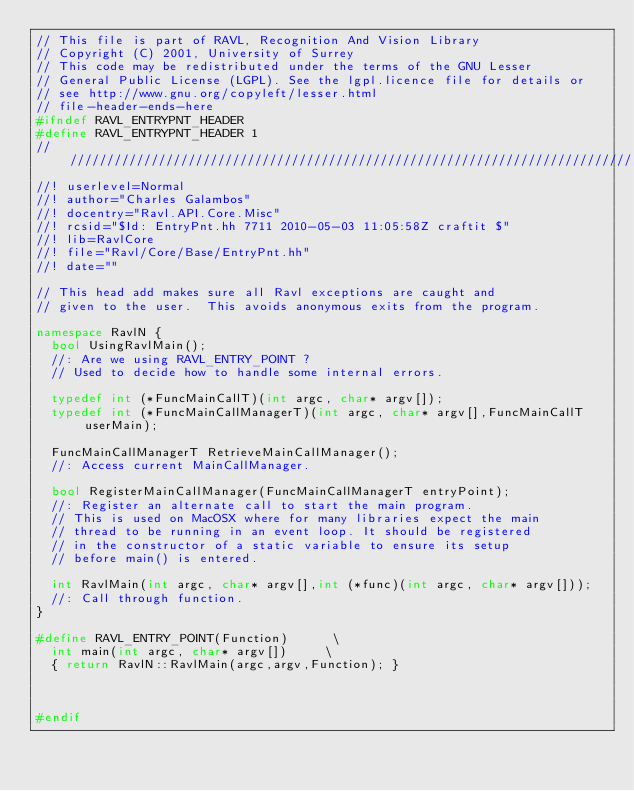<code> <loc_0><loc_0><loc_500><loc_500><_C++_>// This file is part of RAVL, Recognition And Vision Library 
// Copyright (C) 2001, University of Surrey
// This code may be redistributed under the terms of the GNU Lesser
// General Public License (LGPL). See the lgpl.licence file for details or
// see http://www.gnu.org/copyleft/lesser.html
// file-header-ends-here
#ifndef RAVL_ENTRYPNT_HEADER
#define RAVL_ENTRYPNT_HEADER 1
//////////////////////////////////////////////////////////////////////////////
//! userlevel=Normal
//! author="Charles Galambos"
//! docentry="Ravl.API.Core.Misc"
//! rcsid="$Id: EntryPnt.hh 7711 2010-05-03 11:05:58Z craftit $"
//! lib=RavlCore
//! file="Ravl/Core/Base/EntryPnt.hh"
//! date=""

// This head add makes sure all Ravl exceptions are caught and
// given to the user.  This avoids anonymous exits from the program.

namespace RavlN {  
  bool UsingRavlMain();
  //: Are we using RAVL_ENTRY_POINT ?
  // Used to decide how to handle some internal errors.
  
  typedef int (*FuncMainCallT)(int argc, char* argv[]);
  typedef int (*FuncMainCallManagerT)(int argc, char* argv[],FuncMainCallT userMain);

  FuncMainCallManagerT RetrieveMainCallManager();
  //: Access current MainCallManager.

  bool RegisterMainCallManager(FuncMainCallManagerT entryPoint);
  //: Register an alternate call to start the main program.
  // This is used on MacOSX where for many libraries expect the main
  // thread to be running in an event loop. It should be registered
  // in the constructor of a static variable to ensure its setup
  // before main() is entered.

  int RavlMain(int argc, char* argv[],int (*func)(int argc, char* argv[]));
  //: Call through function.
}

#define RAVL_ENTRY_POINT(Function)      \
  int main(int argc, char* argv[])     \
  { return RavlN::RavlMain(argc,argv,Function); }



#endif
</code> 